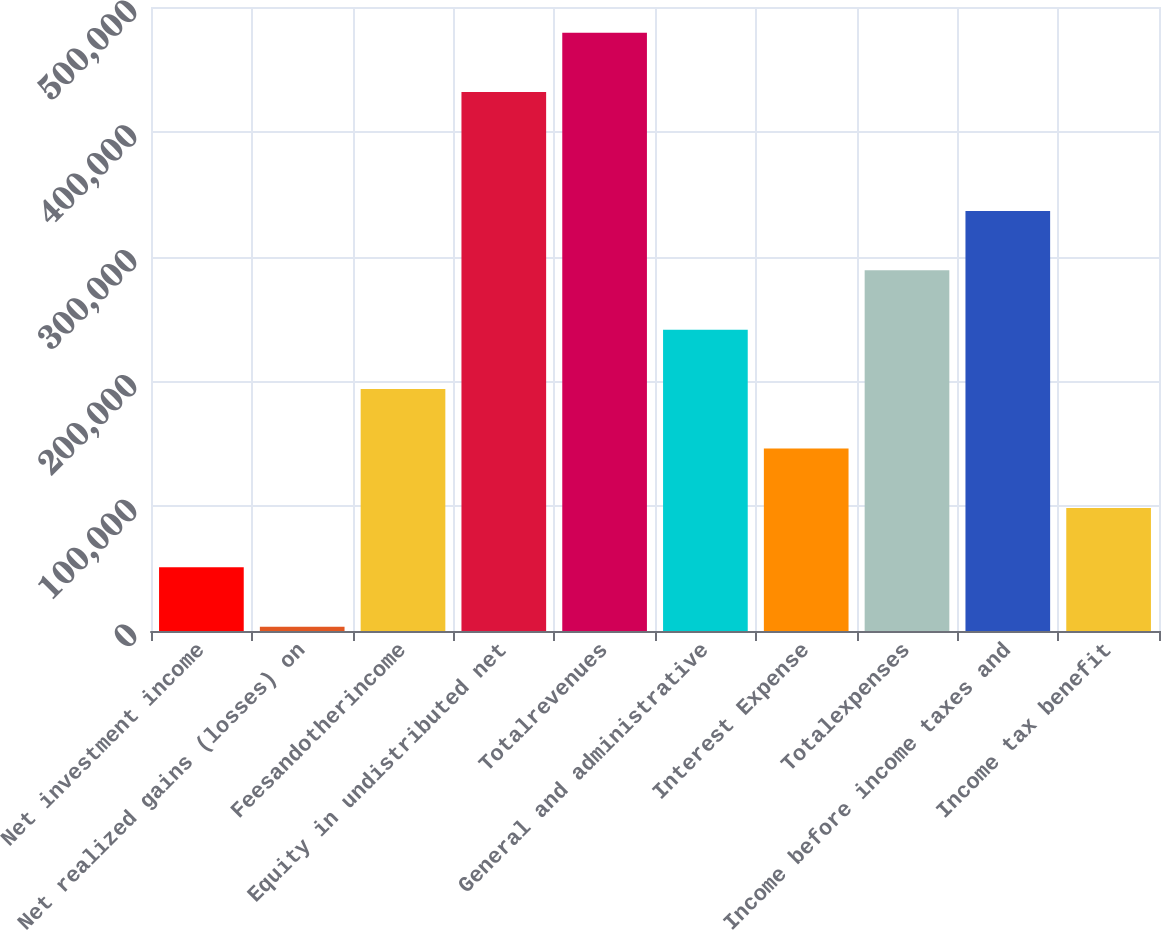<chart> <loc_0><loc_0><loc_500><loc_500><bar_chart><fcel>Net investment income<fcel>Net realized gains (losses) on<fcel>Feesandotherincome<fcel>Equity in undistributed net<fcel>Totalrevenues<fcel>General and administrative<fcel>Interest Expense<fcel>Totalexpenses<fcel>Income before income taxes and<fcel>Income tax benefit<nl><fcel>51014.8<fcel>3411<fcel>193826<fcel>431845<fcel>479449<fcel>241430<fcel>146222<fcel>289034<fcel>336638<fcel>98618.6<nl></chart> 